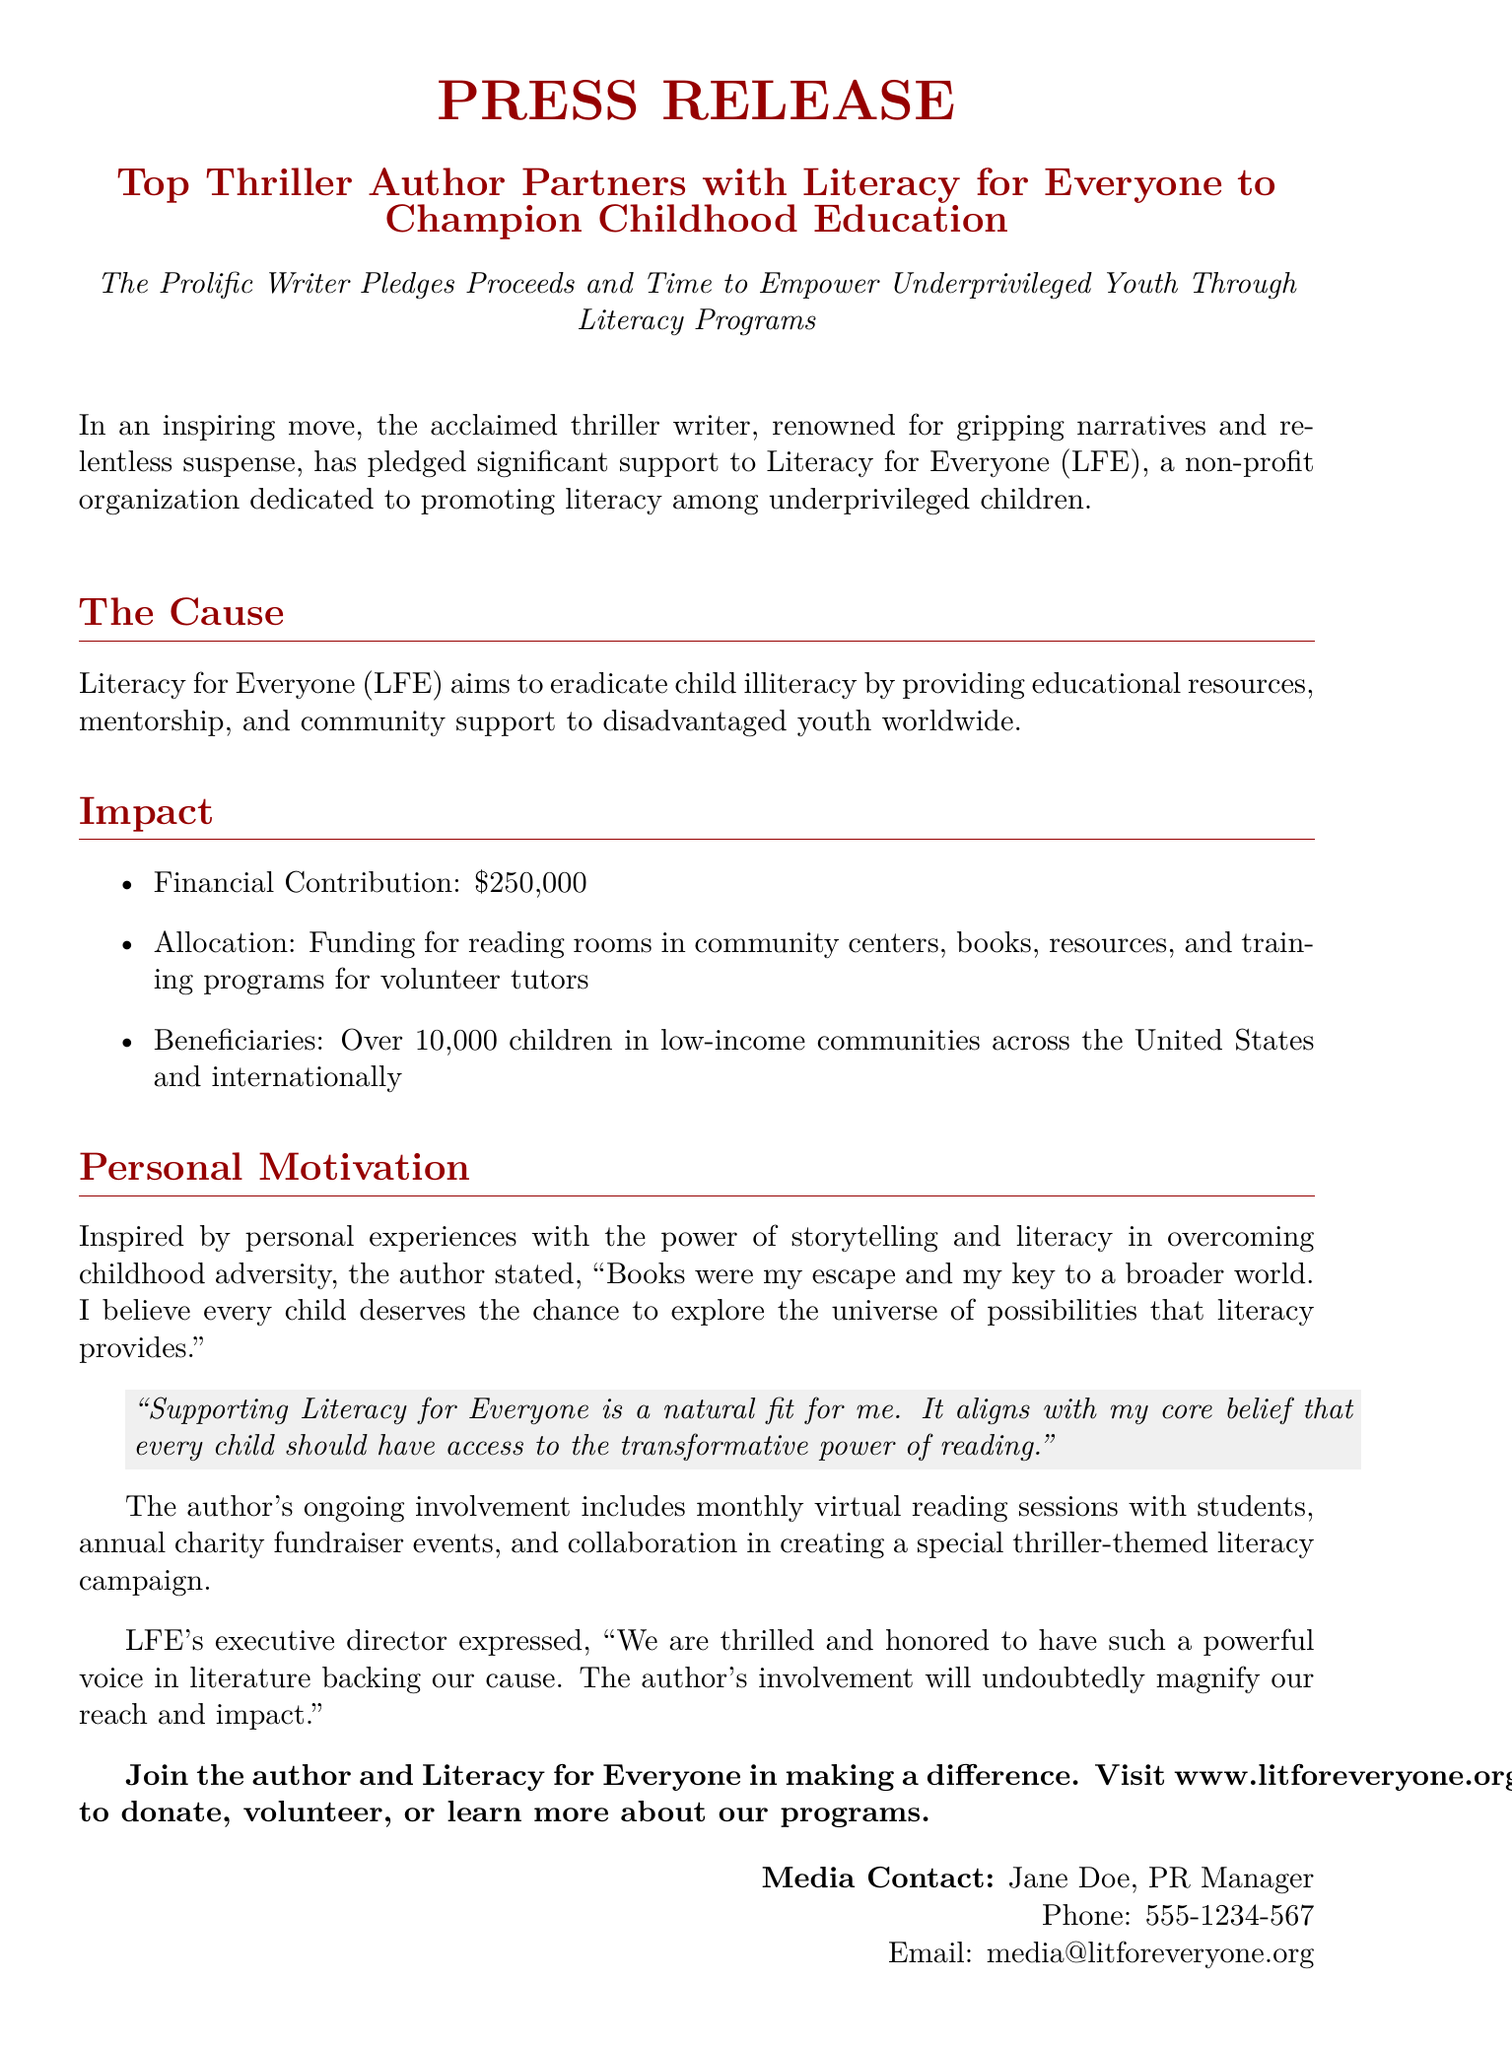What is the name of the non-profit organization? The document identifies the organization as Literacy for Everyone (LFE).
Answer: Literacy for Everyone How much money did the author pledge? The financial contribution pledged by the author is mentioned explicitly in the document.
Answer: $250,000 How many children will benefit from the author's contribution? The document states the projected number of beneficiaries from the initiative.
Answer: Over 10,000 children What personal experience motivated the author to support this cause? The author is motivated by personal experiences related to storytelling and literacy during childhood, as described in the document.
Answer: Childhood adversity What activities is the author involved in with the organization? The document lists specific ongoing activities involving the author that support the charity.
Answer: Monthly virtual reading sessions What is the executive director's sentiment regarding the author's involvement? The sentiment expressed in the document reflects the level of excitement about having the author support the cause.
Answer: Thrilled and honored What does the author believe every child deserves? The document summarizes the author's belief regarding children's rights to literacy.
Answer: The chance to explore the universe of possibilities What type of campaign will the author collaborate on? The document details the nature of the campaign that the author is involved in creating alongside the charity.
Answer: Thriller-themed literacy campaign 